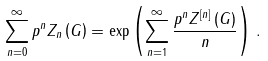Convert formula to latex. <formula><loc_0><loc_0><loc_500><loc_500>\sum _ { n = 0 } ^ { \infty } p ^ { n } Z _ { n } \left ( G \right ) = \exp \left ( \sum _ { n = 1 } ^ { \infty } \frac { p ^ { n } Z ^ { \left [ n \right ] } \left ( G \right ) } { n } \right ) \, .</formula> 